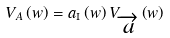<formula> <loc_0><loc_0><loc_500><loc_500>V _ { A } \left ( w \right ) = a _ { \text {I} } \left ( w \right ) V _ { \overrightarrow { a } } \left ( w \right )</formula> 